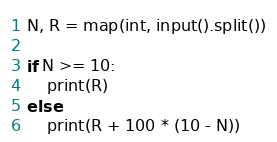Convert code to text. <code><loc_0><loc_0><loc_500><loc_500><_Python_>N, R = map(int, input().split())

if N >= 10:
    print(R)
else:
    print(R + 100 * (10 - N))

</code> 